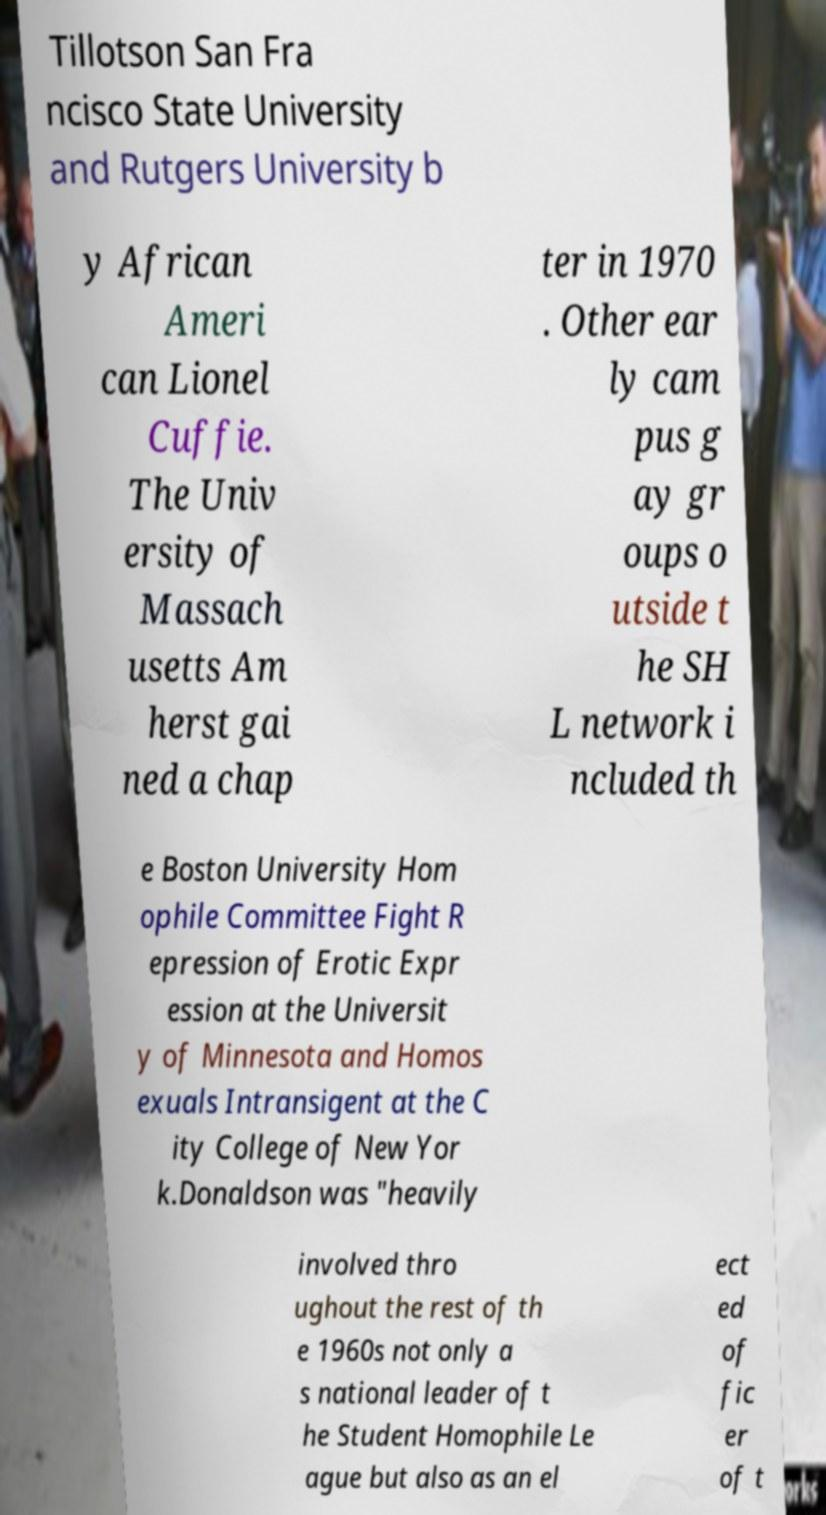Could you extract and type out the text from this image? Tillotson San Fra ncisco State University and Rutgers University b y African Ameri can Lionel Cuffie. The Univ ersity of Massach usetts Am herst gai ned a chap ter in 1970 . Other ear ly cam pus g ay gr oups o utside t he SH L network i ncluded th e Boston University Hom ophile Committee Fight R epression of Erotic Expr ession at the Universit y of Minnesota and Homos exuals Intransigent at the C ity College of New Yor k.Donaldson was "heavily involved thro ughout the rest of th e 1960s not only a s national leader of t he Student Homophile Le ague but also as an el ect ed of fic er of t 